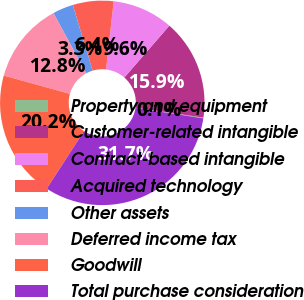Convert chart. <chart><loc_0><loc_0><loc_500><loc_500><pie_chart><fcel>Property and equipment<fcel>Customer-related intangible<fcel>Contract-based intangible<fcel>Acquired technology<fcel>Other assets<fcel>Deferred income tax<fcel>Goodwill<fcel>Total purchase consideration<nl><fcel>0.12%<fcel>15.92%<fcel>9.6%<fcel>6.44%<fcel>3.28%<fcel>12.76%<fcel>20.15%<fcel>31.72%<nl></chart> 